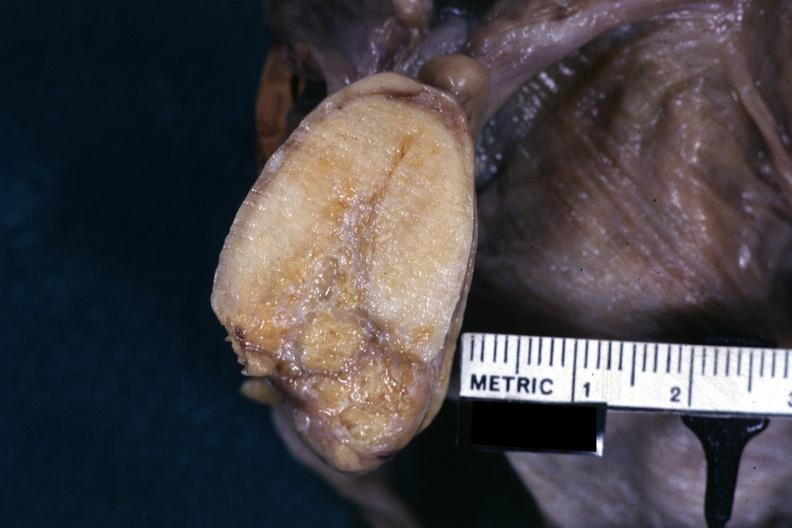s opened uterus and cervix with large cervical myoma protruding into vagina slide present?
Answer the question using a single word or phrase. No 